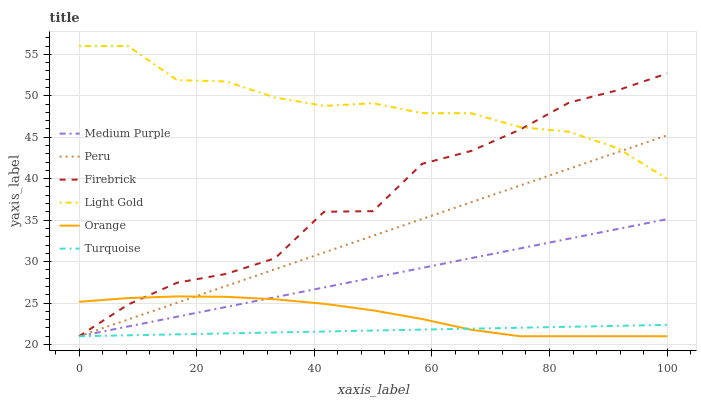Does Turquoise have the minimum area under the curve?
Answer yes or no. Yes. Does Light Gold have the maximum area under the curve?
Answer yes or no. Yes. Does Firebrick have the minimum area under the curve?
Answer yes or no. No. Does Firebrick have the maximum area under the curve?
Answer yes or no. No. Is Medium Purple the smoothest?
Answer yes or no. Yes. Is Firebrick the roughest?
Answer yes or no. Yes. Is Firebrick the smoothest?
Answer yes or no. No. Is Medium Purple the roughest?
Answer yes or no. No. Does Light Gold have the lowest value?
Answer yes or no. No. Does Light Gold have the highest value?
Answer yes or no. Yes. Does Firebrick have the highest value?
Answer yes or no. No. Is Medium Purple less than Light Gold?
Answer yes or no. Yes. Is Light Gold greater than Orange?
Answer yes or no. Yes. Does Peru intersect Medium Purple?
Answer yes or no. Yes. Is Peru less than Medium Purple?
Answer yes or no. No. Is Peru greater than Medium Purple?
Answer yes or no. No. Does Medium Purple intersect Light Gold?
Answer yes or no. No. 